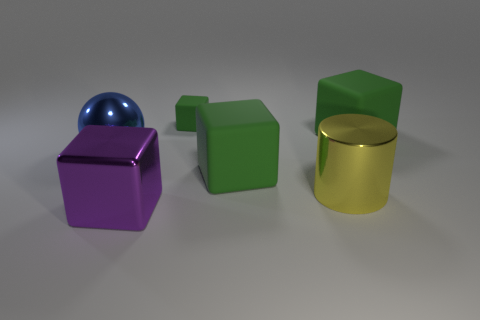Is there a purple ball made of the same material as the blue object?
Your answer should be compact. No. Is the number of purple objects behind the shiny cylinder greater than the number of tiny green rubber cubes that are in front of the blue metallic thing?
Provide a succinct answer. No. How big is the cylinder?
Ensure brevity in your answer.  Large. There is a large rubber object that is right of the yellow cylinder; what is its shape?
Ensure brevity in your answer.  Cube. Does the yellow object have the same shape as the purple metal thing?
Provide a succinct answer. No. Are there an equal number of green things that are in front of the metallic block and green rubber blocks?
Your response must be concise. No. What is the shape of the yellow object?
Offer a terse response. Cylinder. Are there any other things that have the same color as the shiny block?
Make the answer very short. No. There is a matte block to the right of the yellow thing; is its size the same as the block that is in front of the large yellow object?
Give a very brief answer. Yes. What shape is the thing that is in front of the cylinder right of the purple metal object?
Your answer should be compact. Cube. 